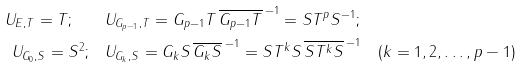Convert formula to latex. <formula><loc_0><loc_0><loc_500><loc_500>U _ { E , T } = T ; \quad & U _ { G _ { p - 1 } , T } = G _ { p - 1 } T \, { \overline { G _ { p - 1 } T } \, } ^ { - 1 } = S T ^ { p } S ^ { - 1 } ; \\ U _ { G _ { 0 } , S } = S ^ { 2 } ; \quad & U _ { G _ { k } , S } = G _ { k } S \, { \overline { G _ { k } S } \, } ^ { - 1 } = S T ^ { k } S \, { \overline { S T ^ { k } S } \, } ^ { - 1 } \quad ( k = 1 , 2 , \dots , p - 1 )</formula> 